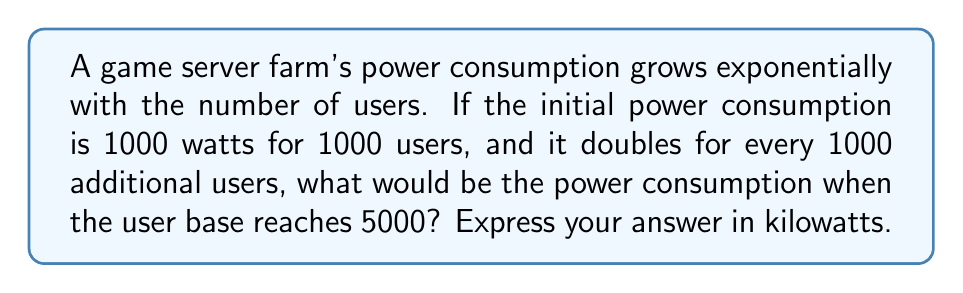Provide a solution to this math problem. Let's approach this step-by-step:

1) First, we need to identify the exponential growth pattern:
   - Initial power: 1000 watts for 1000 users
   - Doubles every 1000 users

2) We can express this as an exponential function:
   $P = 1000 \cdot 2^n$
   Where $P$ is power in watts, and $n$ is the number of 1000-user increments.

3) For 5000 users, we have 4 increments of 1000 users beyond the initial 1000:
   $n = (5000 - 1000) / 1000 = 4$

4) Now we can calculate the power:
   $P = 1000 \cdot 2^4$

5) Simplify:
   $P = 1000 \cdot 16 = 16000$ watts

6) Convert to kilowatts:
   $16000 \text{ watts} = 16 \text{ kilowatts}$

This exponential growth model is crucial in game server architecture, as it helps in capacity planning and optimizing power consumption as the user base scales.
Answer: 16 kW 